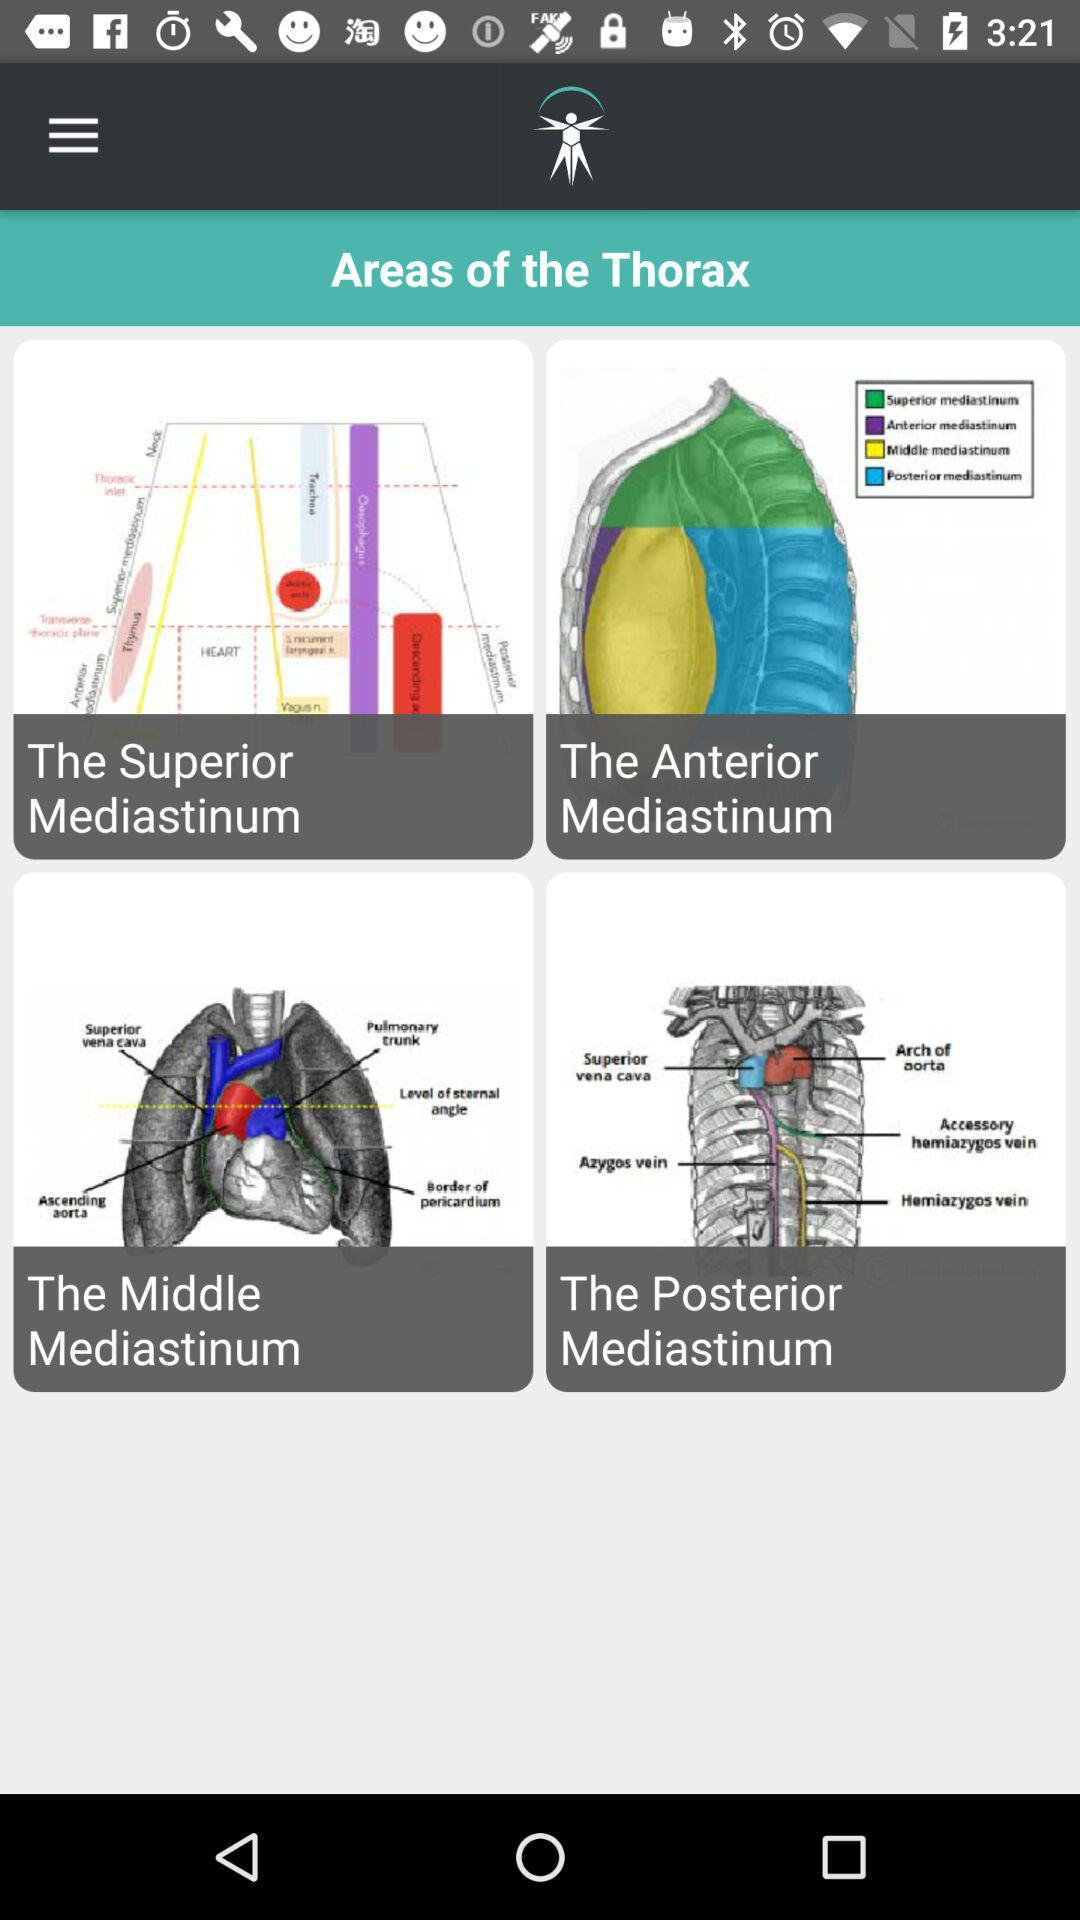What are the areas of the thorax? The areas of the thorax are "The Superior Mediastinum", "The Anterior Mediastinum", "The Middle Mediastinum" and "The Posterior Mediastinum". 